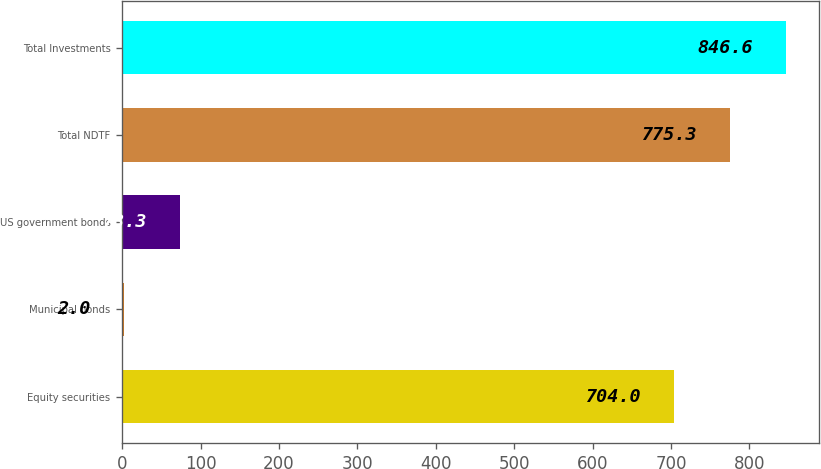Convert chart. <chart><loc_0><loc_0><loc_500><loc_500><bar_chart><fcel>Equity securities<fcel>Municipal bonds<fcel>US government bonds<fcel>Total NDTF<fcel>Total Investments<nl><fcel>704<fcel>2<fcel>73.3<fcel>775.3<fcel>846.6<nl></chart> 